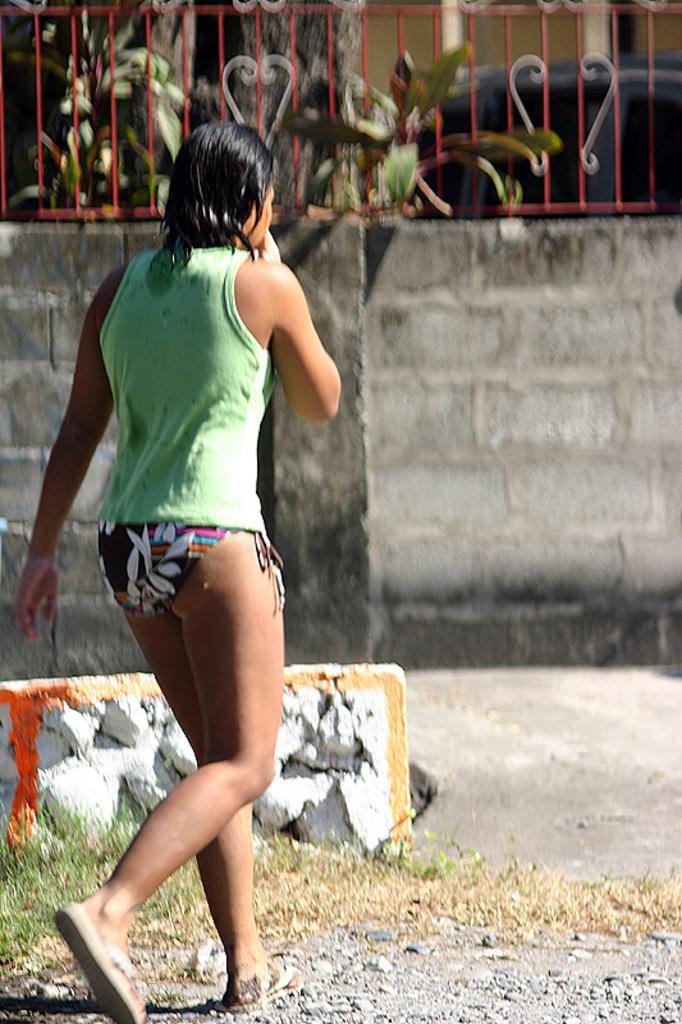Could you give a brief overview of what you see in this image? In this image there is a lady walking, beside her there is a wall with rocks, behind this wall there is another wall with bricks and the top of the wall there is a railing. In the background of the image there are trees and a vehicle parked. 